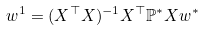<formula> <loc_0><loc_0><loc_500><loc_500>w ^ { 1 } & = ( X ^ { \top } X ) ^ { - 1 } X ^ { \top } \mathbb { P ^ { * } } X w ^ { * }</formula> 